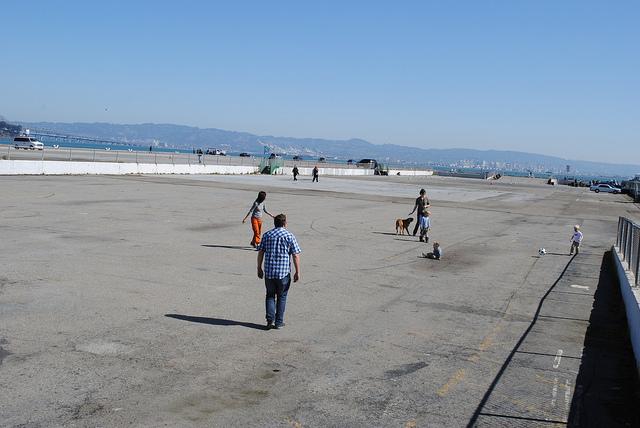Where was this picture taken?
Answer briefly. Parking lot. How many kids in this photo?
Give a very brief answer. 3. Are the people on a soft surface?
Be succinct. No. 